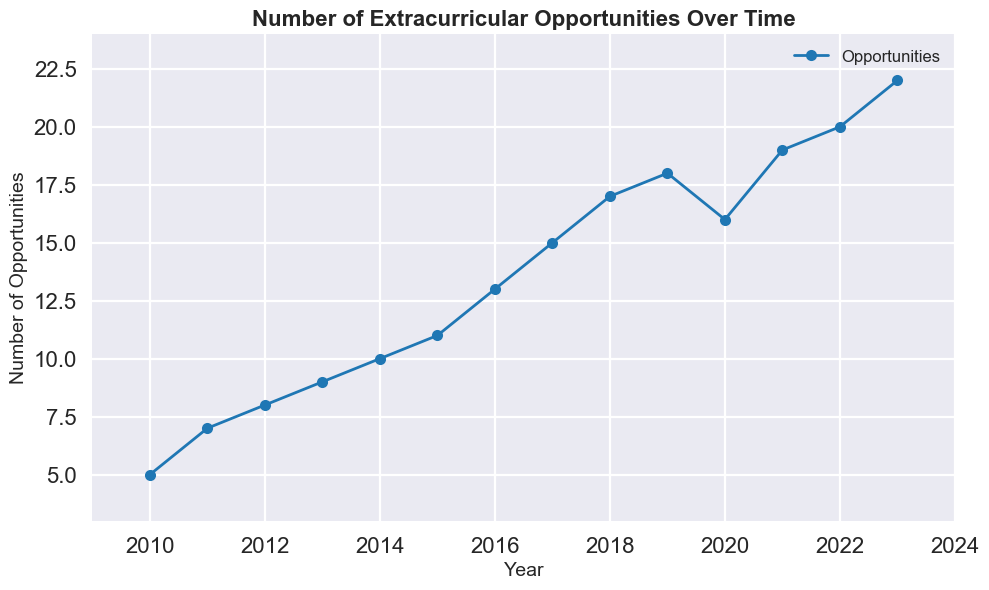What is the general trend in the number of extracurricular opportunities from 2010 to 2023? The line chart shows an overall upward trend in the number of extracurricular opportunities, starting from 5 in 2010 and reaching 22 in 2023. Despite a small dip from 2019 to 2020, the overall trend is increasing.
Answer: Increasing In which year was there a noticeable drop in the number of extracurricular opportunities? Observing the line chart, we see that the number of opportunities dropped from 18 in 2019 to 16 in 2020, marking the only noticeable drop over the years.
Answer: 2020 How many extracurricular opportunities were available in 2015, and how does this number compare to 2017? In 2015, there were 11 opportunities available, whereas in 2017, there were 15. By comparing these years, we see that the number of opportunities increased by 4 from 2015 to 2017.
Answer: Increased by 4 Calculate the average number of extracurricular opportunities available from 2010 to 2015. The numbers for the years 2010 to 2015 are 5, 7, 8, 9, 10, and 11 respectively. Adding these up gives 5 + 7 + 8 + 9 + 10 + 11 = 50. Dividing by 6 (the number of years) yields an average of 50/6 ≈ 8.33.
Answer: 8.33 What is the highest number of extracurricular opportunities available, and in which year is this observed? From the chart, the highest number is 22, which occurs in the year 2023.
Answer: 22 in 2023 Compare the number of extracurricular opportunities in 2020 and 2021. By what percentage did the opportunities increase or decrease? In 2020, there were 16 opportunities, and in 2021, there were 19. The increase is calculated as (19 - 16)/16 * 100% = 3/16 * 100% = 18.75%.
Answer: Increased by 18.75% How does the number of extracurricular opportunities in 2013 compare to 2019? In 2013, there were 9 opportunities, and in 2019, there were 18. The number of opportunities in 2019 is double that of 2013.
Answer: Double What is the difference in the number of extracurricular opportunities between the years 2011 and 2023? In 2011, there were 7 opportunities, and in 2023, there were 22. The difference is 22 - 7 = 15.
Answer: 15 What is the median number of extracurricular opportunities for the years 2010 to 2018? Listing the numbers for these years: 5, 7, 8, 9, 10, 11, 13, 15, 17. As there are an odd number of data points (9), the median is the middle value when sorted, which is 10.
Answer: 10 If the trend from 2021 to 2023 continues, what would be the projected number of extracurricular opportunities in 2024? Observing the increase from 2021 (19) to 2023 (22), the average yearly increase is (22 - 19)/2 = 1.5. Adding 1.5 to the 2023 value gives 22 + 1.5 = 23.5, which can be approximated to 24.
Answer: 24 